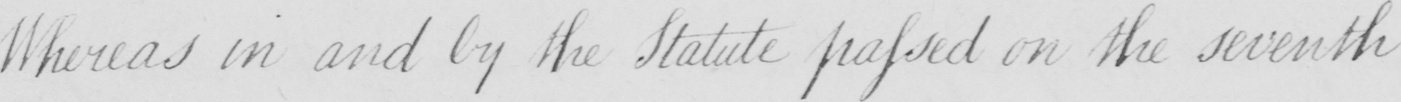What text is written in this handwritten line? Whereas in and by the Statute passed on the seventh 